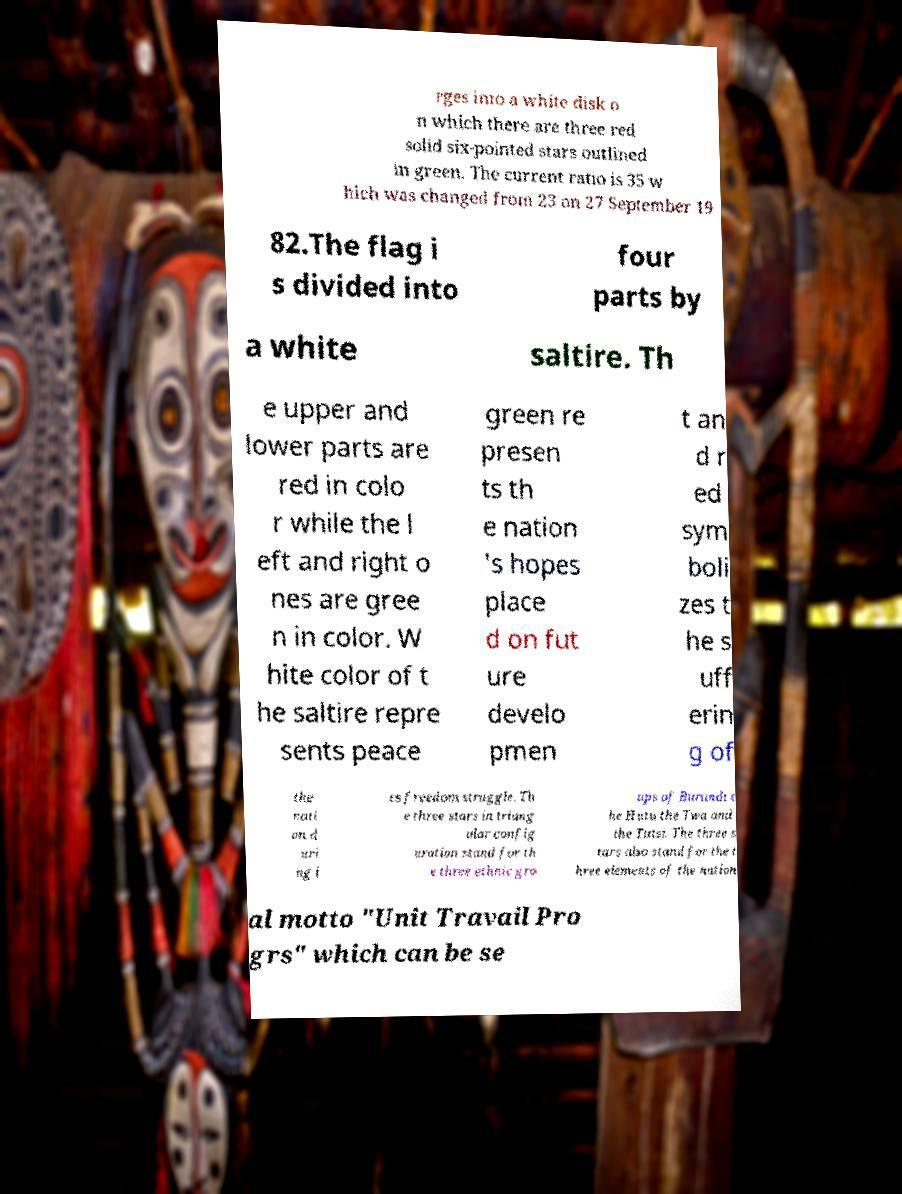Can you accurately transcribe the text from the provided image for me? rges into a white disk o n which there are three red solid six-pointed stars outlined in green. The current ratio is 35 w hich was changed from 23 on 27 September 19 82.The flag i s divided into four parts by a white saltire. Th e upper and lower parts are red in colo r while the l eft and right o nes are gree n in color. W hite color of t he saltire repre sents peace green re presen ts th e nation 's hopes place d on fut ure develo pmen t an d r ed sym boli zes t he s uff erin g of the nati on d uri ng i ts freedom struggle. Th e three stars in triang ular config uration stand for th e three ethnic gro ups of Burundi t he Hutu the Twa and the Tutsi. The three s tars also stand for the t hree elements of the nation al motto "Unit Travail Pro grs" which can be se 